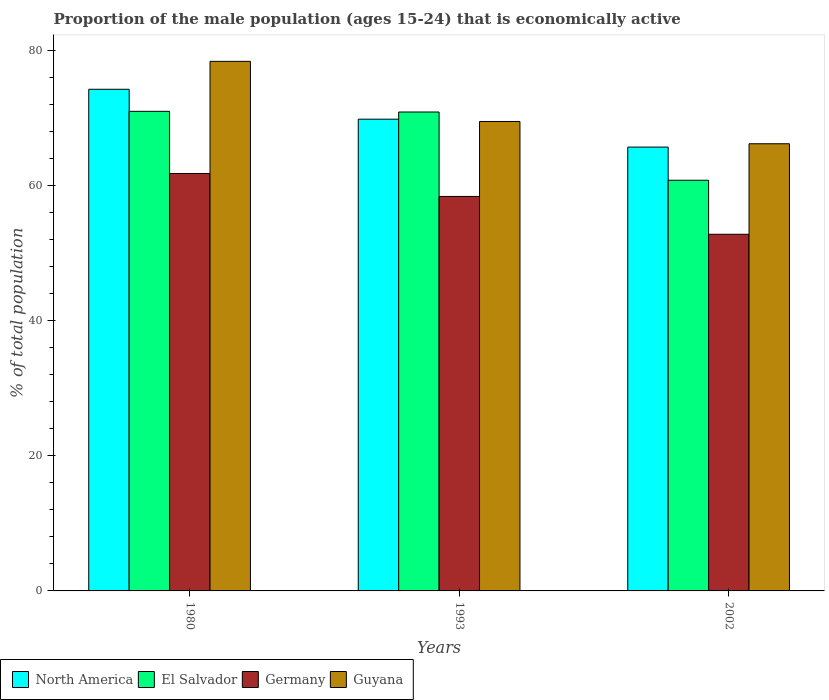How many groups of bars are there?
Offer a very short reply. 3. Are the number of bars per tick equal to the number of legend labels?
Your answer should be very brief. Yes. What is the label of the 2nd group of bars from the left?
Offer a very short reply. 1993. In how many cases, is the number of bars for a given year not equal to the number of legend labels?
Provide a succinct answer. 0. What is the proportion of the male population that is economically active in El Salvador in 1993?
Offer a very short reply. 70.9. Across all years, what is the maximum proportion of the male population that is economically active in Germany?
Provide a succinct answer. 61.8. Across all years, what is the minimum proportion of the male population that is economically active in Germany?
Provide a short and direct response. 52.8. What is the total proportion of the male population that is economically active in North America in the graph?
Provide a short and direct response. 209.81. What is the difference between the proportion of the male population that is economically active in Guyana in 1980 and that in 1993?
Offer a very short reply. 8.9. What is the difference between the proportion of the male population that is economically active in El Salvador in 1993 and the proportion of the male population that is economically active in Germany in 1980?
Your answer should be compact. 9.1. What is the average proportion of the male population that is economically active in Guyana per year?
Ensure brevity in your answer.  71.37. In the year 2002, what is the difference between the proportion of the male population that is economically active in Germany and proportion of the male population that is economically active in Guyana?
Keep it short and to the point. -13.4. In how many years, is the proportion of the male population that is economically active in El Salvador greater than 76 %?
Your response must be concise. 0. What is the ratio of the proportion of the male population that is economically active in Germany in 1980 to that in 1993?
Give a very brief answer. 1.06. Is the proportion of the male population that is economically active in Germany in 1980 less than that in 1993?
Keep it short and to the point. No. What is the difference between the highest and the second highest proportion of the male population that is economically active in El Salvador?
Your answer should be very brief. 0.1. What is the difference between the highest and the lowest proportion of the male population that is economically active in El Salvador?
Ensure brevity in your answer.  10.2. In how many years, is the proportion of the male population that is economically active in El Salvador greater than the average proportion of the male population that is economically active in El Salvador taken over all years?
Make the answer very short. 2. Is the sum of the proportion of the male population that is economically active in El Salvador in 1980 and 1993 greater than the maximum proportion of the male population that is economically active in North America across all years?
Keep it short and to the point. Yes. Is it the case that in every year, the sum of the proportion of the male population that is economically active in North America and proportion of the male population that is economically active in El Salvador is greater than the sum of proportion of the male population that is economically active in Germany and proportion of the male population that is economically active in Guyana?
Provide a short and direct response. No. Is it the case that in every year, the sum of the proportion of the male population that is economically active in Guyana and proportion of the male population that is economically active in El Salvador is greater than the proportion of the male population that is economically active in Germany?
Make the answer very short. Yes. How many years are there in the graph?
Give a very brief answer. 3. What is the difference between two consecutive major ticks on the Y-axis?
Offer a terse response. 20. Are the values on the major ticks of Y-axis written in scientific E-notation?
Offer a very short reply. No. Does the graph contain any zero values?
Offer a terse response. No. Where does the legend appear in the graph?
Your answer should be very brief. Bottom left. What is the title of the graph?
Ensure brevity in your answer.  Proportion of the male population (ages 15-24) that is economically active. What is the label or title of the X-axis?
Keep it short and to the point. Years. What is the label or title of the Y-axis?
Offer a terse response. % of total population. What is the % of total population in North America in 1980?
Make the answer very short. 74.27. What is the % of total population in El Salvador in 1980?
Keep it short and to the point. 71. What is the % of total population in Germany in 1980?
Offer a terse response. 61.8. What is the % of total population in Guyana in 1980?
Make the answer very short. 78.4. What is the % of total population of North America in 1993?
Give a very brief answer. 69.84. What is the % of total population in El Salvador in 1993?
Give a very brief answer. 70.9. What is the % of total population in Germany in 1993?
Provide a short and direct response. 58.4. What is the % of total population in Guyana in 1993?
Give a very brief answer. 69.5. What is the % of total population in North America in 2002?
Your answer should be compact. 65.71. What is the % of total population of El Salvador in 2002?
Offer a terse response. 60.8. What is the % of total population of Germany in 2002?
Offer a very short reply. 52.8. What is the % of total population in Guyana in 2002?
Offer a very short reply. 66.2. Across all years, what is the maximum % of total population in North America?
Give a very brief answer. 74.27. Across all years, what is the maximum % of total population of El Salvador?
Your answer should be very brief. 71. Across all years, what is the maximum % of total population of Germany?
Provide a succinct answer. 61.8. Across all years, what is the maximum % of total population of Guyana?
Make the answer very short. 78.4. Across all years, what is the minimum % of total population in North America?
Your response must be concise. 65.71. Across all years, what is the minimum % of total population of El Salvador?
Offer a very short reply. 60.8. Across all years, what is the minimum % of total population of Germany?
Ensure brevity in your answer.  52.8. Across all years, what is the minimum % of total population of Guyana?
Your answer should be very brief. 66.2. What is the total % of total population of North America in the graph?
Provide a succinct answer. 209.81. What is the total % of total population in El Salvador in the graph?
Make the answer very short. 202.7. What is the total % of total population of Germany in the graph?
Offer a terse response. 173. What is the total % of total population in Guyana in the graph?
Keep it short and to the point. 214.1. What is the difference between the % of total population of North America in 1980 and that in 1993?
Ensure brevity in your answer.  4.43. What is the difference between the % of total population of Guyana in 1980 and that in 1993?
Make the answer very short. 8.9. What is the difference between the % of total population in North America in 1980 and that in 2002?
Offer a very short reply. 8.56. What is the difference between the % of total population of El Salvador in 1980 and that in 2002?
Ensure brevity in your answer.  10.2. What is the difference between the % of total population of Germany in 1980 and that in 2002?
Give a very brief answer. 9. What is the difference between the % of total population in North America in 1993 and that in 2002?
Your answer should be compact. 4.13. What is the difference between the % of total population in El Salvador in 1993 and that in 2002?
Offer a very short reply. 10.1. What is the difference between the % of total population in Guyana in 1993 and that in 2002?
Offer a very short reply. 3.3. What is the difference between the % of total population in North America in 1980 and the % of total population in El Salvador in 1993?
Offer a terse response. 3.37. What is the difference between the % of total population in North America in 1980 and the % of total population in Germany in 1993?
Provide a short and direct response. 15.87. What is the difference between the % of total population of North America in 1980 and the % of total population of Guyana in 1993?
Keep it short and to the point. 4.77. What is the difference between the % of total population in El Salvador in 1980 and the % of total population in Guyana in 1993?
Provide a short and direct response. 1.5. What is the difference between the % of total population in North America in 1980 and the % of total population in El Salvador in 2002?
Ensure brevity in your answer.  13.47. What is the difference between the % of total population in North America in 1980 and the % of total population in Germany in 2002?
Your answer should be very brief. 21.47. What is the difference between the % of total population in North America in 1980 and the % of total population in Guyana in 2002?
Provide a short and direct response. 8.07. What is the difference between the % of total population in Germany in 1980 and the % of total population in Guyana in 2002?
Your response must be concise. -4.4. What is the difference between the % of total population of North America in 1993 and the % of total population of El Salvador in 2002?
Give a very brief answer. 9.04. What is the difference between the % of total population of North America in 1993 and the % of total population of Germany in 2002?
Provide a succinct answer. 17.04. What is the difference between the % of total population of North America in 1993 and the % of total population of Guyana in 2002?
Give a very brief answer. 3.64. What is the difference between the % of total population in El Salvador in 1993 and the % of total population in Germany in 2002?
Your response must be concise. 18.1. What is the difference between the % of total population in El Salvador in 1993 and the % of total population in Guyana in 2002?
Offer a terse response. 4.7. What is the average % of total population in North America per year?
Provide a succinct answer. 69.94. What is the average % of total population in El Salvador per year?
Give a very brief answer. 67.57. What is the average % of total population in Germany per year?
Offer a terse response. 57.67. What is the average % of total population in Guyana per year?
Ensure brevity in your answer.  71.37. In the year 1980, what is the difference between the % of total population of North America and % of total population of El Salvador?
Keep it short and to the point. 3.27. In the year 1980, what is the difference between the % of total population in North America and % of total population in Germany?
Give a very brief answer. 12.47. In the year 1980, what is the difference between the % of total population of North America and % of total population of Guyana?
Keep it short and to the point. -4.13. In the year 1980, what is the difference between the % of total population of Germany and % of total population of Guyana?
Your response must be concise. -16.6. In the year 1993, what is the difference between the % of total population of North America and % of total population of El Salvador?
Keep it short and to the point. -1.06. In the year 1993, what is the difference between the % of total population in North America and % of total population in Germany?
Make the answer very short. 11.44. In the year 1993, what is the difference between the % of total population in North America and % of total population in Guyana?
Your answer should be very brief. 0.34. In the year 1993, what is the difference between the % of total population of El Salvador and % of total population of Germany?
Make the answer very short. 12.5. In the year 2002, what is the difference between the % of total population of North America and % of total population of El Salvador?
Your answer should be very brief. 4.91. In the year 2002, what is the difference between the % of total population in North America and % of total population in Germany?
Provide a short and direct response. 12.91. In the year 2002, what is the difference between the % of total population of North America and % of total population of Guyana?
Your answer should be very brief. -0.49. In the year 2002, what is the difference between the % of total population of Germany and % of total population of Guyana?
Give a very brief answer. -13.4. What is the ratio of the % of total population in North America in 1980 to that in 1993?
Provide a succinct answer. 1.06. What is the ratio of the % of total population in El Salvador in 1980 to that in 1993?
Keep it short and to the point. 1. What is the ratio of the % of total population of Germany in 1980 to that in 1993?
Make the answer very short. 1.06. What is the ratio of the % of total population of Guyana in 1980 to that in 1993?
Provide a short and direct response. 1.13. What is the ratio of the % of total population of North America in 1980 to that in 2002?
Your response must be concise. 1.13. What is the ratio of the % of total population of El Salvador in 1980 to that in 2002?
Your answer should be compact. 1.17. What is the ratio of the % of total population of Germany in 1980 to that in 2002?
Keep it short and to the point. 1.17. What is the ratio of the % of total population of Guyana in 1980 to that in 2002?
Keep it short and to the point. 1.18. What is the ratio of the % of total population of North America in 1993 to that in 2002?
Provide a succinct answer. 1.06. What is the ratio of the % of total population in El Salvador in 1993 to that in 2002?
Keep it short and to the point. 1.17. What is the ratio of the % of total population in Germany in 1993 to that in 2002?
Give a very brief answer. 1.11. What is the ratio of the % of total population in Guyana in 1993 to that in 2002?
Offer a terse response. 1.05. What is the difference between the highest and the second highest % of total population of North America?
Offer a very short reply. 4.43. What is the difference between the highest and the second highest % of total population in Germany?
Provide a short and direct response. 3.4. What is the difference between the highest and the second highest % of total population of Guyana?
Provide a short and direct response. 8.9. What is the difference between the highest and the lowest % of total population of North America?
Provide a short and direct response. 8.56. What is the difference between the highest and the lowest % of total population in El Salvador?
Your answer should be compact. 10.2. What is the difference between the highest and the lowest % of total population in Germany?
Ensure brevity in your answer.  9. What is the difference between the highest and the lowest % of total population of Guyana?
Ensure brevity in your answer.  12.2. 